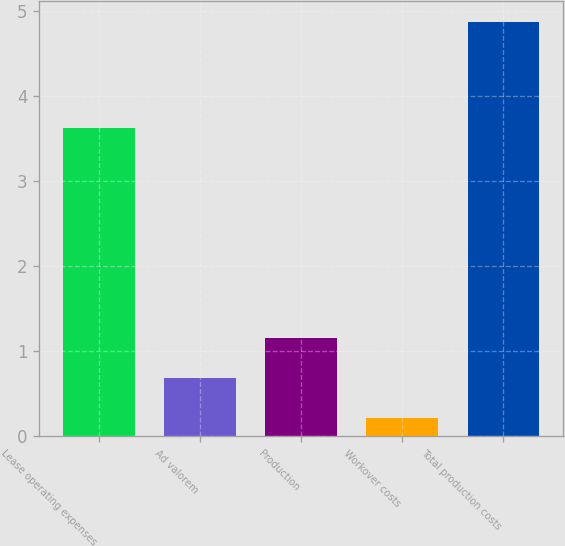<chart> <loc_0><loc_0><loc_500><loc_500><bar_chart><fcel>Lease operating expenses<fcel>Ad valorem<fcel>Production<fcel>Workover costs<fcel>Total production costs<nl><fcel>3.63<fcel>0.68<fcel>1.15<fcel>0.21<fcel>4.88<nl></chart> 